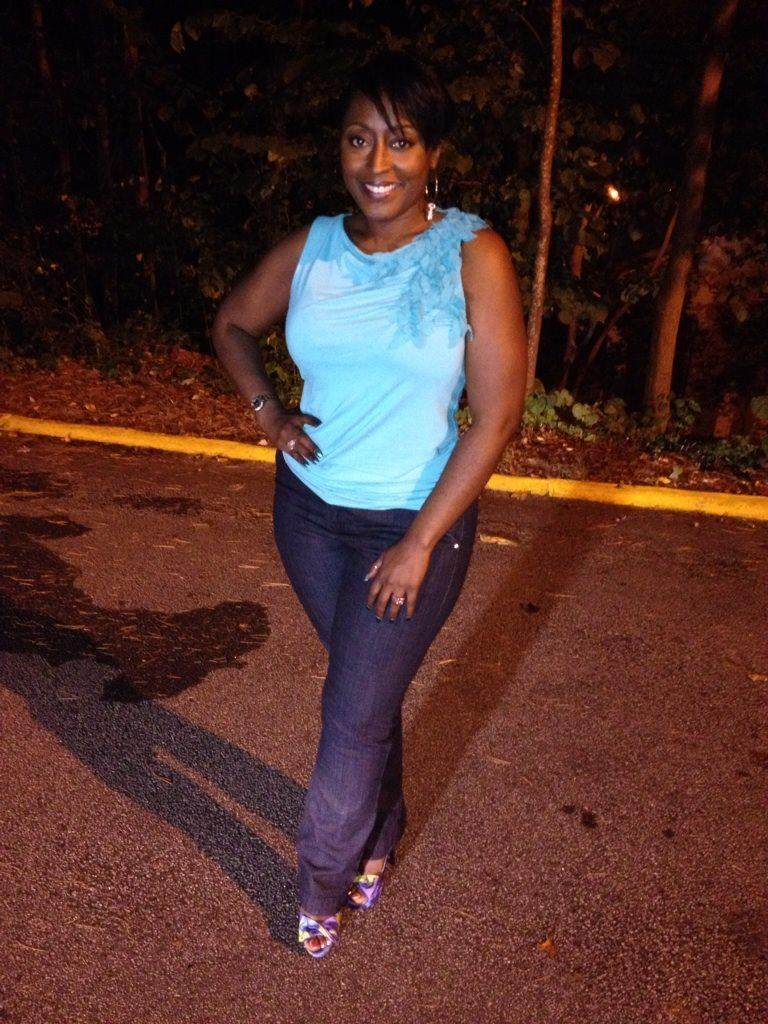What is the main subject of the image? There is a person standing in the center of the image. What is the person's position relative to the ground? The person is standing on the ground. What can be seen in the background of the image? There are trees visible in the background of the image. What type of vest is the person wearing in the image? There is no vest visible in the image; the person is not wearing any clothing mentioned in the facts. 